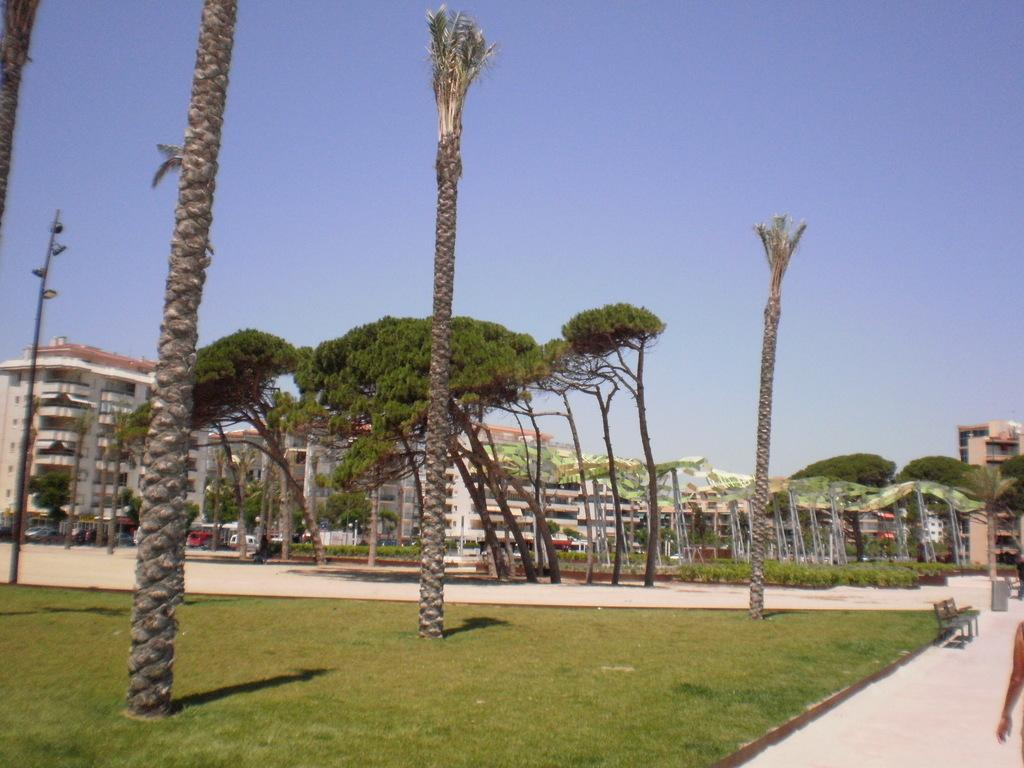What type of vegetation is present in the image? There is grass in the image. What type of seating is visible in the image? There is a bench in the image. What type of natural structures are present in the image? There are trees in the image. What type of man-made structure is present in the image? There is a pole in the image. What can be seen in the background of the image? There are buildings, vehicles, and the sky visible in the background of the image. Whose hand is visible on the right side of the image? There is a person's hand on the right side of the image. What type of behavior is exhibited by the rabbit in the image? There is no rabbit present in the image. Who is the representative of the group in the image? There is no group or representative mentioned in the image. 